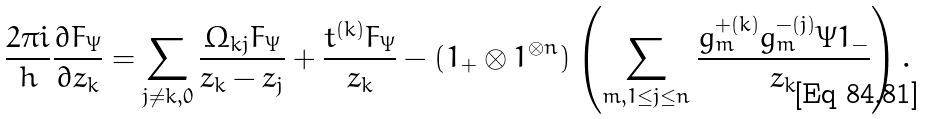<formula> <loc_0><loc_0><loc_500><loc_500>\frac { 2 \pi i } { h } \frac { \partial F _ { \Psi } } { \partial z _ { k } } & = \sum _ { j \neq k , 0 } \frac { \Omega _ { k j } F _ { \Psi } } { z _ { k } - z _ { j } } + \frac { t ^ { ( k ) } F _ { \Psi } } { z _ { k } } - ( 1 _ { + } \otimes 1 ^ { \otimes n } ) \left ( \sum _ { m , 1 \leq j \leq n } \frac { g _ { m } ^ { + ( k ) } g _ { m } ^ { - ( j ) } \Psi 1 _ { - } } { z _ { k } } \right ) .</formula> 